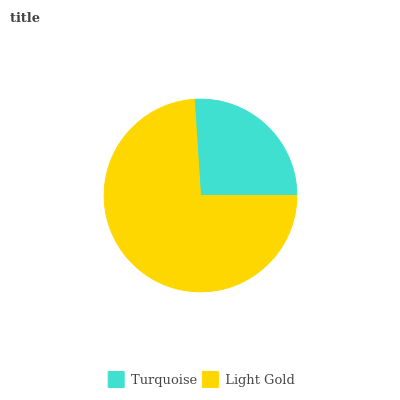Is Turquoise the minimum?
Answer yes or no. Yes. Is Light Gold the maximum?
Answer yes or no. Yes. Is Light Gold the minimum?
Answer yes or no. No. Is Light Gold greater than Turquoise?
Answer yes or no. Yes. Is Turquoise less than Light Gold?
Answer yes or no. Yes. Is Turquoise greater than Light Gold?
Answer yes or no. No. Is Light Gold less than Turquoise?
Answer yes or no. No. Is Light Gold the high median?
Answer yes or no. Yes. Is Turquoise the low median?
Answer yes or no. Yes. Is Turquoise the high median?
Answer yes or no. No. Is Light Gold the low median?
Answer yes or no. No. 